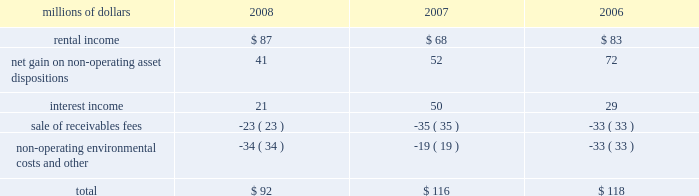The pension plan investments are held in a master trust , with the northern trust company .
Investments in the master trust are valued at fair value , which has been determined based on fair value of the underlying investments of the master trust .
Investments in securities traded on public security exchanges are valued at their closing market prices on the valuation date ; where no sale was made on the valuation date , the security is generally valued at its most recent bid price .
Certain short-term investments are carried at cost , which approximates fair value .
Investments in registered investment companies and common trust funds , which primarily invest in stocks , bonds , and commodity futures , are valued using publicly available market prices for the underlying investments held by these entities .
The majority of pension plan assets are invested in equity securities , because equity portfolios have historically provided higher returns than debt and other asset classes over extended time horizons , and are expected to do so in the future .
Correspondingly , equity investments also entail greater risks than other investments .
Equity risks are balanced by investing a significant portion of the plan 2019s assets in high quality debt securities .
The average quality rating of the debt portfolio exceeded aa as of december 31 , 2008 and 2007 .
The debt portfolio is also broadly diversified and invested primarily in u.s .
Treasury , mortgage , and corporate securities with an intermediate average maturity .
The weighted-average maturity of the debt portfolio was 5 years at both december 31 , 2008 and 2007 , respectively .
The investment of pension plan assets in securities issued by union pacific is specifically prohibited for both the equity and debt portfolios , other than through index fund holdings .
Other retirement programs thrift plan 2013 we provide a defined contribution plan ( thrift plan ) to eligible non-union employees and make matching contributions to the thrift plan .
We match 50 cents for each dollar contributed by employees up to the first six percent of compensation contributed .
Our thrift plan contributions were $ 14 million in 2008 , $ 14 million in 2007 , and $ 13 million in 2006 .
Railroad retirement system 2013 all railroad employees are covered by the railroad retirement system ( the system ) .
Contributions made to the system are expensed as incurred and amounted to approximately $ 620 million in 2008 , $ 616 million in 2007 , and $ 615 million in 2006 .
Collective bargaining agreements 2013 under collective bargaining agreements , we provide certain postretirement healthcare and life insurance benefits for eligible union employees .
Premiums under the plans are expensed as incurred and amounted to $ 49 million in 2008 and $ 40 million in both 2007 and 5 .
Other income other income included the following for the years ended december 31 : millions of dollars 2008 2007 2006 .

What was the percentage change in rental income from 2007 to 2008? 
Computations: ((87 - 68) / 68)
Answer: 0.27941. 